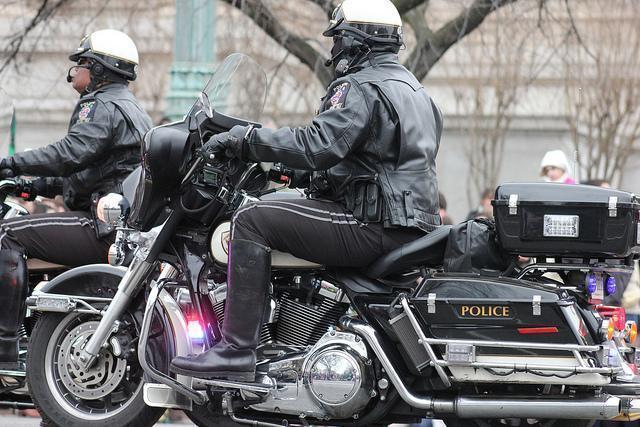What would be one main reason a police would be riding this type of motorcycle?
Choose the right answer from the provided options to respond to the question.
Options: Functionality, easy access, looks, speed. Looks. 